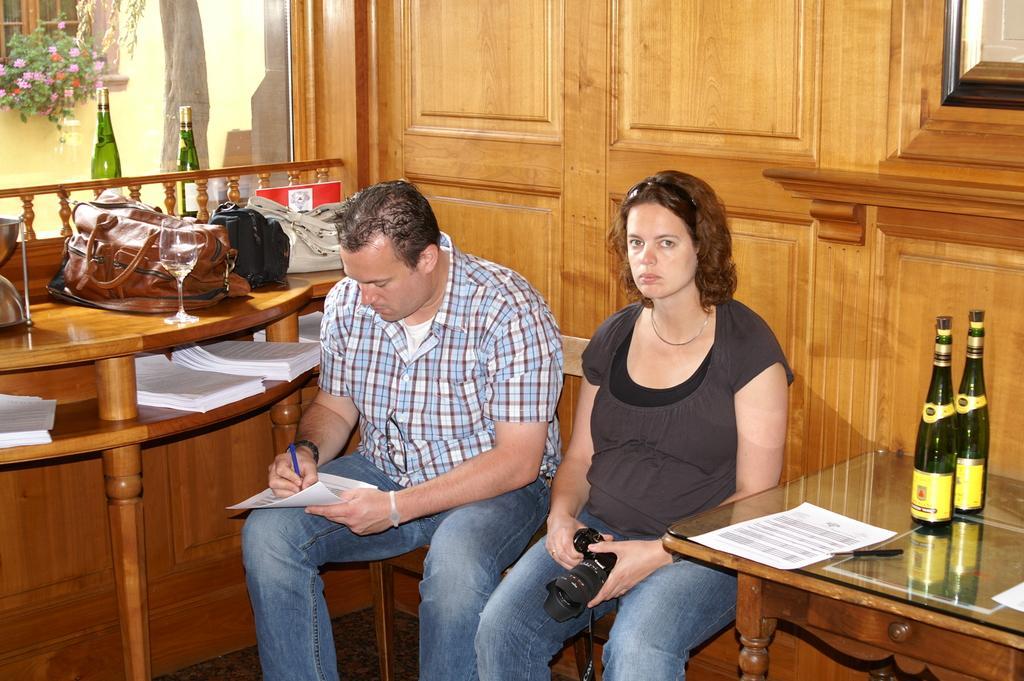How would you summarize this image in a sentence or two? The picture is taken inside a room. there are two person sitting on chairs. In the right side one lady is sitting wearing a gray t shirt and jeans holding a camera. Beside her a man wearing checked shirt is writing something on the paper. Beside him there is table with bags, bottles and glass and some papers on there. In the right side there is a table on the table there is bottle, papers. In the left top corner there is flower plant. The background is wooden furniture. 